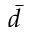<formula> <loc_0><loc_0><loc_500><loc_500>\bar { d }</formula> 